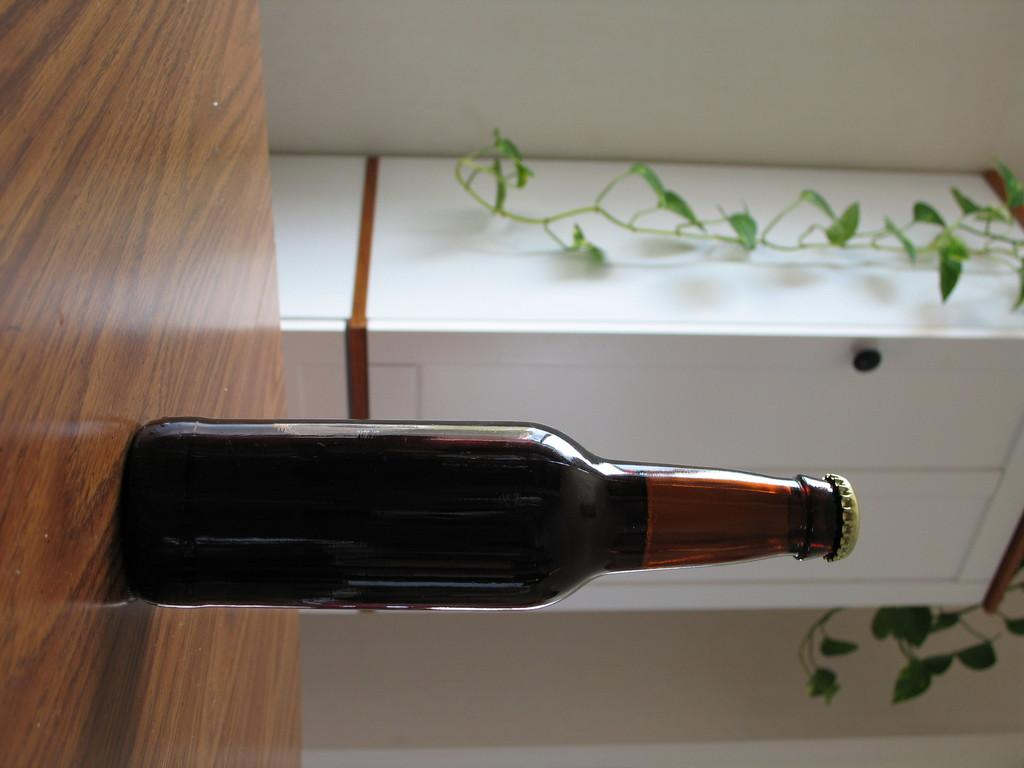What object can be seen in the image? There is a bottle in the image. Where is the bottle located? The bottle is placed on a table. What can be seen in the background of the image? There is a plant, a cupboard, and a wall in the background of the image. What type of guitar is leaning against the wall in the image? There is no guitar present in the image; it only features a bottle, a table, a plant, a cupboard, and a wall. 